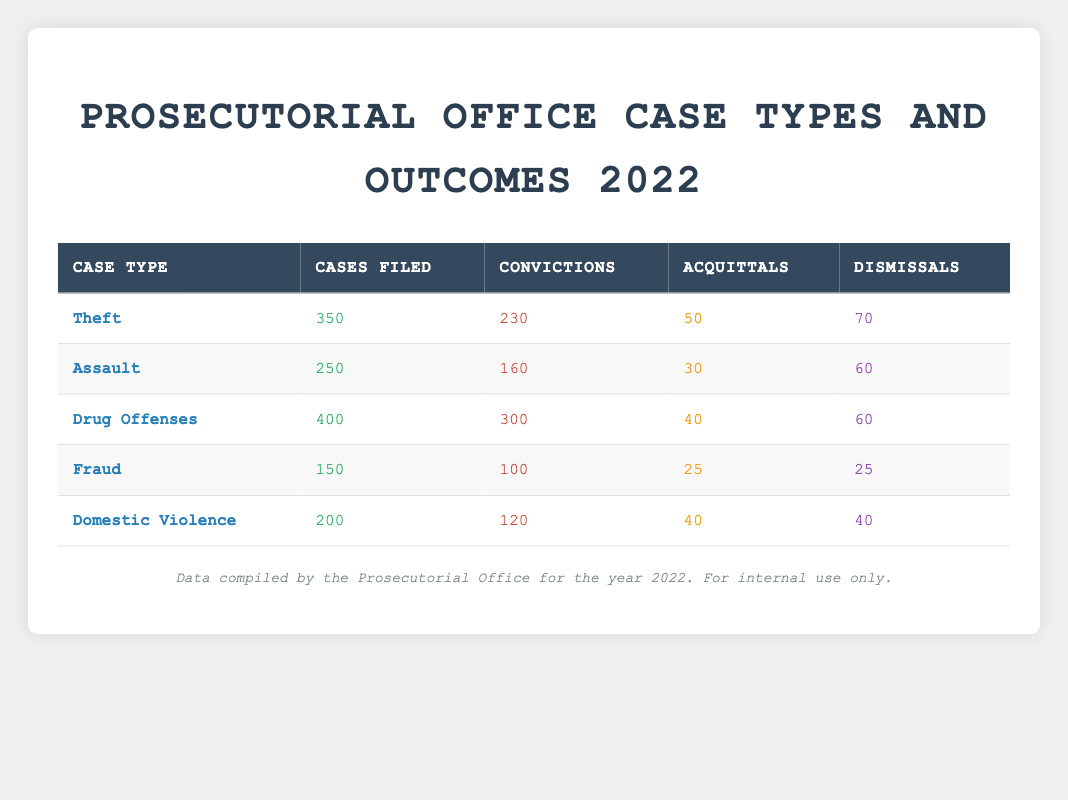What is the total number of cases filed in 2022? To find the total number of cases filed, I need to sum the "Cases Filed" for all case types. That is 350 (Theft) + 250 (Assault) + 400 (Drug Offenses) + 150 (Fraud) + 200 (Domestic Violence) = 1400.
Answer: 1400 How many convictions were obtained from Theft cases? The table indicates that there were 230 convictions resulting from Theft cases. This is listed directly under the "Convictions" column for the Theft row.
Answer: 230 Which case type had the highest number of dismissals? I will look at the "Dismissals" column for each case type. The values are 70 (Theft), 60 (Assault), 60 (Drug Offenses), 25 (Fraud), and 40 (Domestic Violence). The highest value is 70 for Theft.
Answer: Theft What percentage of Drug Offenses resulted in convictions? To find the percentage of convictions for Drug Offenses, I divide the number of convictions by the total cases filed and then multiply by 100. That is (300 convictions / 400 cases filed) * 100 = 75%.
Answer: 75% Did Domestic Violence have more convictions than Assault? Comparing the "Convictions" for both case types, Domestic Violence has 120 convictions while Assault has 160. 120 is less than 160, so the statement is false.
Answer: No What is the average number of acquittals across all case types? I'll add the number of acquittals for each case type: 50 (Theft) + 30 (Assault) + 40 (Drug Offenses) + 25 (Fraud) + 40 (Domestic Violence) = 185. To get the average, I divide by the number of case types, which is 5. Thus, 185 / 5 = 37.
Answer: 37 How many more cases were filed for Drug Offenses than for Fraud? I subtract the cases filed for Fraud from those filed for Drug Offenses. That is 400 (Drug Offenses) - 150 (Fraud) = 250.
Answer: 250 Is the number of acquittals for Fraud greater than that for Domestic Violence? Fraud has 25 acquittals while Domestic Violence has 40. Since 25 is less than 40, the answer is no.
Answer: No What is the total number of outcomes for the Assault case type? To find the total outcomes for Assault, I will sum the convictions, acquittals, and dismissals. That is 160 (Convictions) + 30 (Acquittals) + 60 (Dismissals) = 250.
Answer: 250 